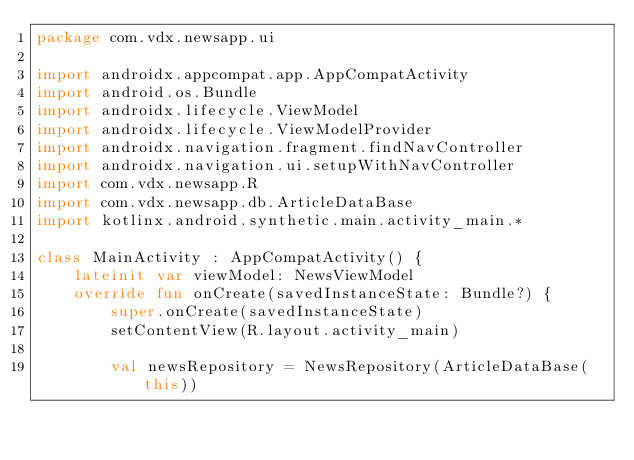Convert code to text. <code><loc_0><loc_0><loc_500><loc_500><_Kotlin_>package com.vdx.newsapp.ui

import androidx.appcompat.app.AppCompatActivity
import android.os.Bundle
import androidx.lifecycle.ViewModel
import androidx.lifecycle.ViewModelProvider
import androidx.navigation.fragment.findNavController
import androidx.navigation.ui.setupWithNavController
import com.vdx.newsapp.R
import com.vdx.newsapp.db.ArticleDataBase
import kotlinx.android.synthetic.main.activity_main.*

class MainActivity : AppCompatActivity() {
    lateinit var viewModel: NewsViewModel
    override fun onCreate(savedInstanceState: Bundle?) {
        super.onCreate(savedInstanceState)
        setContentView(R.layout.activity_main)

        val newsRepository = NewsRepository(ArticleDataBase(this))</code> 